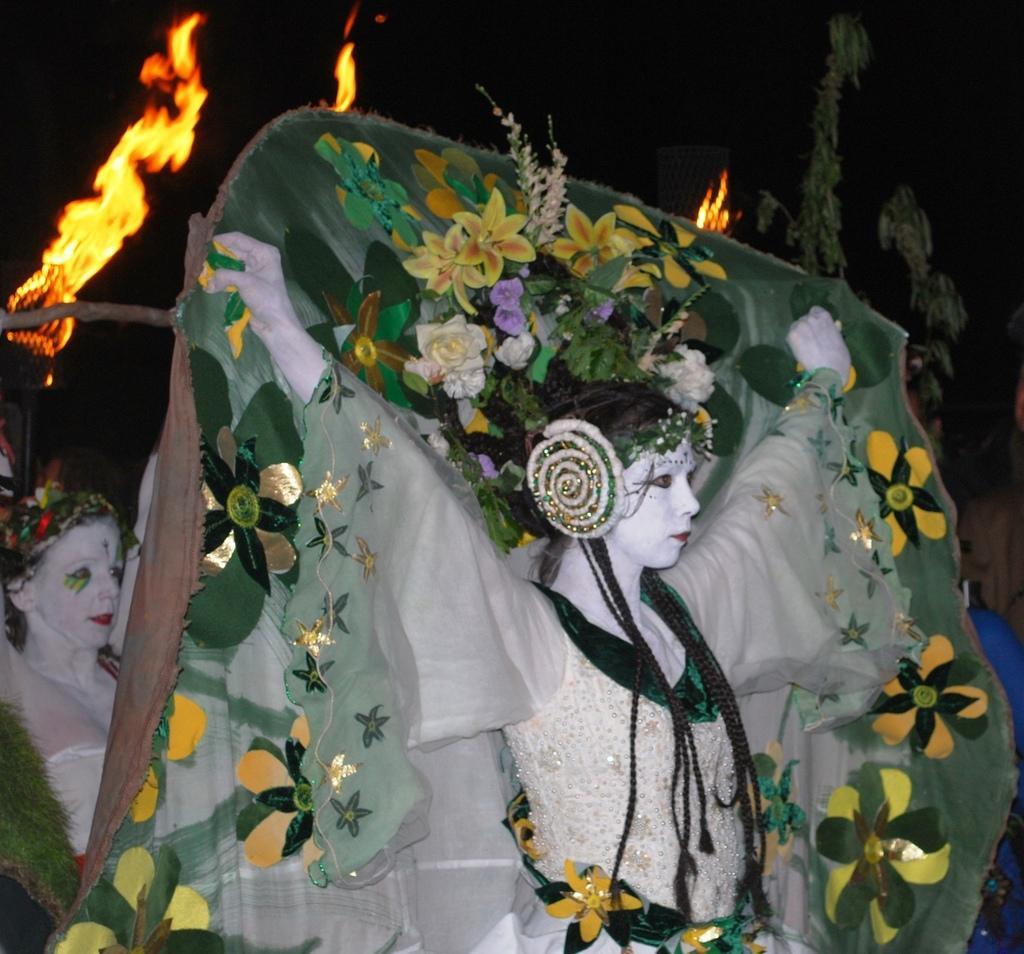Please provide a concise description of this image. In this image, we can see people are wearing costumes. Background we can see fire, leaves and dark view. 